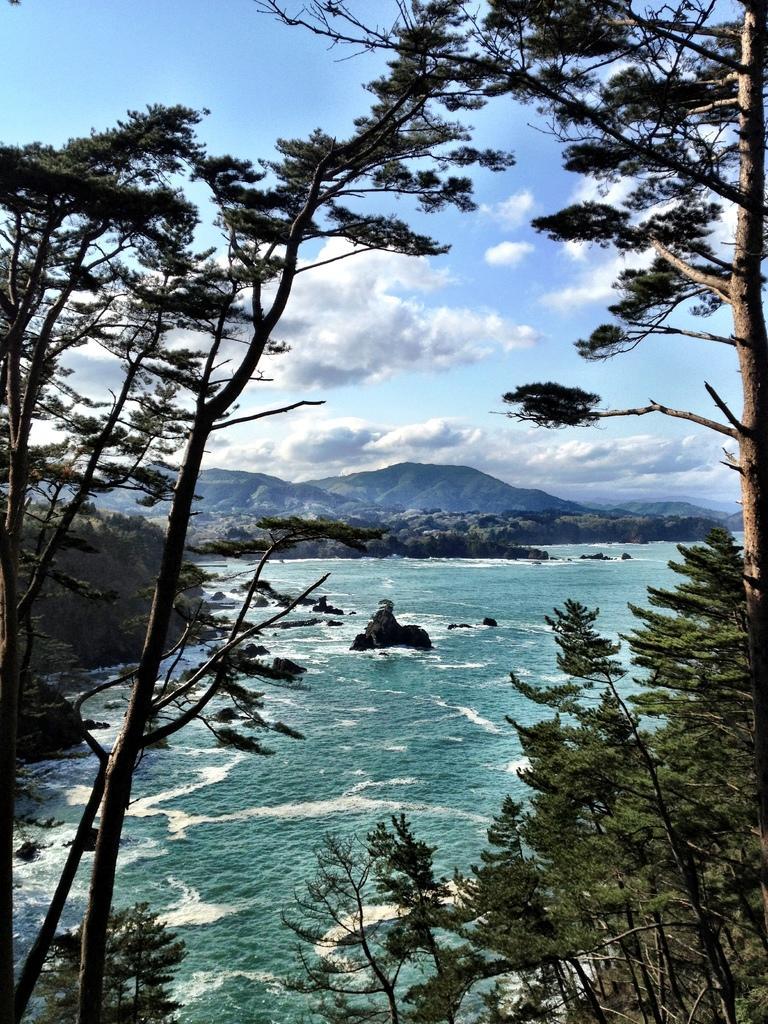How would you summarize this image in a sentence or two? There are trees and water. In the background there are hills and sky with clouds. 